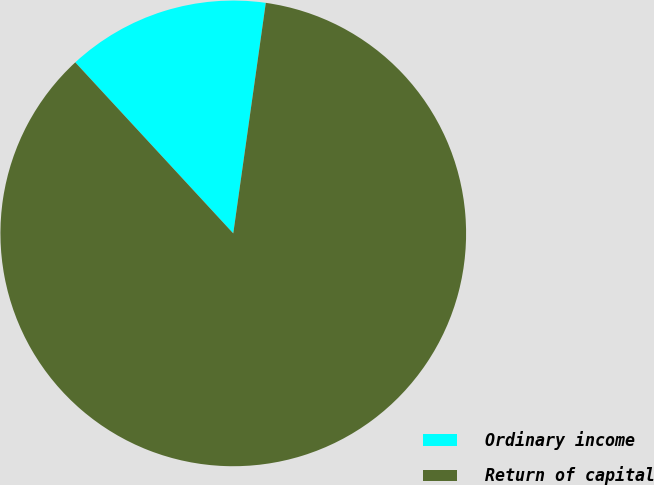<chart> <loc_0><loc_0><loc_500><loc_500><pie_chart><fcel>Ordinary income<fcel>Return of capital<nl><fcel>14.1%<fcel>85.9%<nl></chart> 